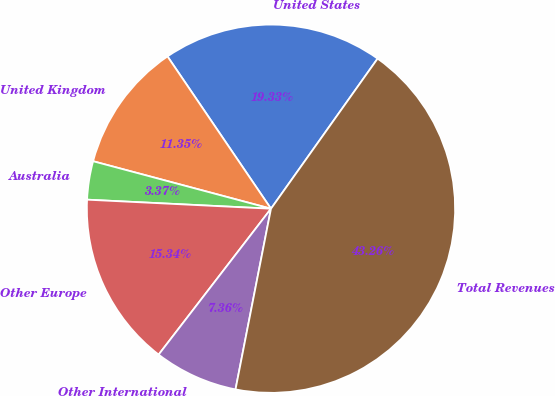Convert chart to OTSL. <chart><loc_0><loc_0><loc_500><loc_500><pie_chart><fcel>United States<fcel>United Kingdom<fcel>Australia<fcel>Other Europe<fcel>Other International<fcel>Total Revenues<nl><fcel>19.33%<fcel>11.35%<fcel>3.37%<fcel>15.34%<fcel>7.36%<fcel>43.26%<nl></chart> 